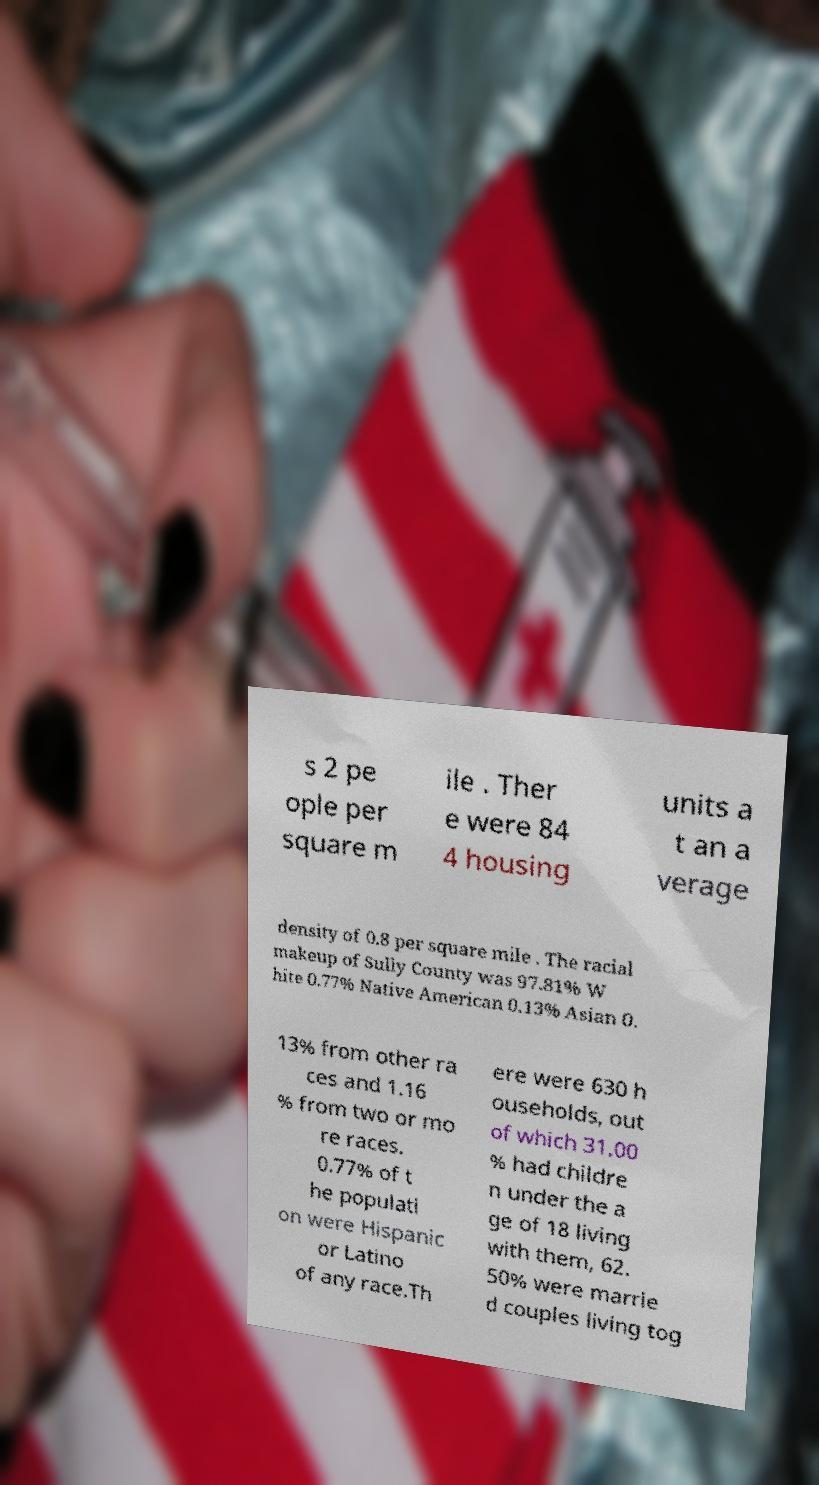For documentation purposes, I need the text within this image transcribed. Could you provide that? s 2 pe ople per square m ile . Ther e were 84 4 housing units a t an a verage density of 0.8 per square mile . The racial makeup of Sully County was 97.81% W hite 0.77% Native American 0.13% Asian 0. 13% from other ra ces and 1.16 % from two or mo re races. 0.77% of t he populati on were Hispanic or Latino of any race.Th ere were 630 h ouseholds, out of which 31.00 % had childre n under the a ge of 18 living with them, 62. 50% were marrie d couples living tog 